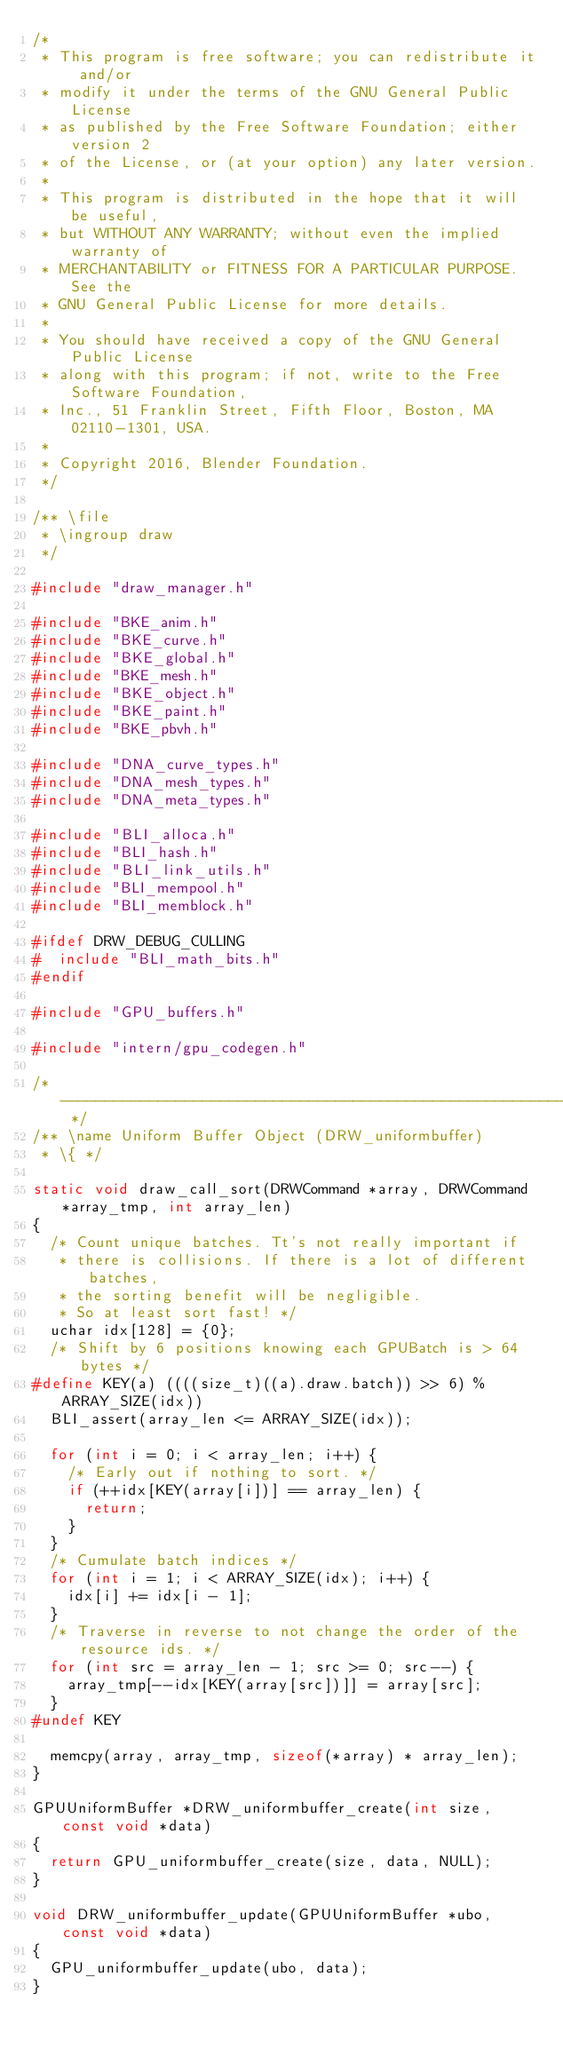<code> <loc_0><loc_0><loc_500><loc_500><_C_>/*
 * This program is free software; you can redistribute it and/or
 * modify it under the terms of the GNU General Public License
 * as published by the Free Software Foundation; either version 2
 * of the License, or (at your option) any later version.
 *
 * This program is distributed in the hope that it will be useful,
 * but WITHOUT ANY WARRANTY; without even the implied warranty of
 * MERCHANTABILITY or FITNESS FOR A PARTICULAR PURPOSE.  See the
 * GNU General Public License for more details.
 *
 * You should have received a copy of the GNU General Public License
 * along with this program; if not, write to the Free Software Foundation,
 * Inc., 51 Franklin Street, Fifth Floor, Boston, MA 02110-1301, USA.
 *
 * Copyright 2016, Blender Foundation.
 */

/** \file
 * \ingroup draw
 */

#include "draw_manager.h"

#include "BKE_anim.h"
#include "BKE_curve.h"
#include "BKE_global.h"
#include "BKE_mesh.h"
#include "BKE_object.h"
#include "BKE_paint.h"
#include "BKE_pbvh.h"

#include "DNA_curve_types.h"
#include "DNA_mesh_types.h"
#include "DNA_meta_types.h"

#include "BLI_alloca.h"
#include "BLI_hash.h"
#include "BLI_link_utils.h"
#include "BLI_mempool.h"
#include "BLI_memblock.h"

#ifdef DRW_DEBUG_CULLING
#  include "BLI_math_bits.h"
#endif

#include "GPU_buffers.h"

#include "intern/gpu_codegen.h"

/* -------------------------------------------------------------------- */
/** \name Uniform Buffer Object (DRW_uniformbuffer)
 * \{ */

static void draw_call_sort(DRWCommand *array, DRWCommand *array_tmp, int array_len)
{
  /* Count unique batches. Tt's not really important if
   * there is collisions. If there is a lot of different batches,
   * the sorting benefit will be negligible.
   * So at least sort fast! */
  uchar idx[128] = {0};
  /* Shift by 6 positions knowing each GPUBatch is > 64 bytes */
#define KEY(a) ((((size_t)((a).draw.batch)) >> 6) % ARRAY_SIZE(idx))
  BLI_assert(array_len <= ARRAY_SIZE(idx));

  for (int i = 0; i < array_len; i++) {
    /* Early out if nothing to sort. */
    if (++idx[KEY(array[i])] == array_len) {
      return;
    }
  }
  /* Cumulate batch indices */
  for (int i = 1; i < ARRAY_SIZE(idx); i++) {
    idx[i] += idx[i - 1];
  }
  /* Traverse in reverse to not change the order of the resource ids. */
  for (int src = array_len - 1; src >= 0; src--) {
    array_tmp[--idx[KEY(array[src])]] = array[src];
  }
#undef KEY

  memcpy(array, array_tmp, sizeof(*array) * array_len);
}

GPUUniformBuffer *DRW_uniformbuffer_create(int size, const void *data)
{
  return GPU_uniformbuffer_create(size, data, NULL);
}

void DRW_uniformbuffer_update(GPUUniformBuffer *ubo, const void *data)
{
  GPU_uniformbuffer_update(ubo, data);
}
</code> 